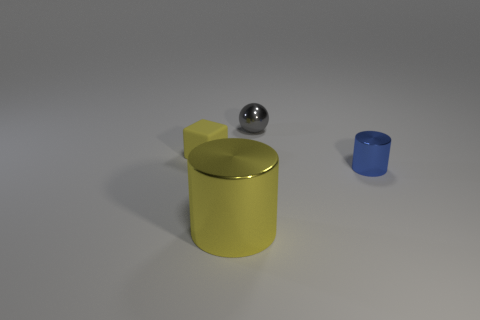Are there any other things that have the same size as the yellow shiny cylinder?
Your answer should be compact. No. What number of matte things are either tiny cyan things or small objects?
Your response must be concise. 1. Is there a purple ball?
Offer a terse response. No. Is the shape of the blue metallic object the same as the yellow shiny thing?
Provide a succinct answer. Yes. There is a metal thing that is left of the shiny object behind the small blue object; how many yellow objects are left of it?
Your response must be concise. 1. There is a small object that is both in front of the tiny gray ball and to the left of the blue shiny thing; what is its material?
Offer a terse response. Rubber. What color is the thing that is both in front of the small yellow matte block and left of the tiny gray metallic thing?
Your response must be concise. Yellow. Are there any other things that have the same color as the big thing?
Provide a succinct answer. Yes. There is a yellow matte object that is behind the shiny cylinder that is to the left of the metal cylinder that is right of the small gray shiny sphere; what is its shape?
Provide a succinct answer. Cube. What color is the large shiny thing that is the same shape as the tiny blue thing?
Your answer should be very brief. Yellow. 